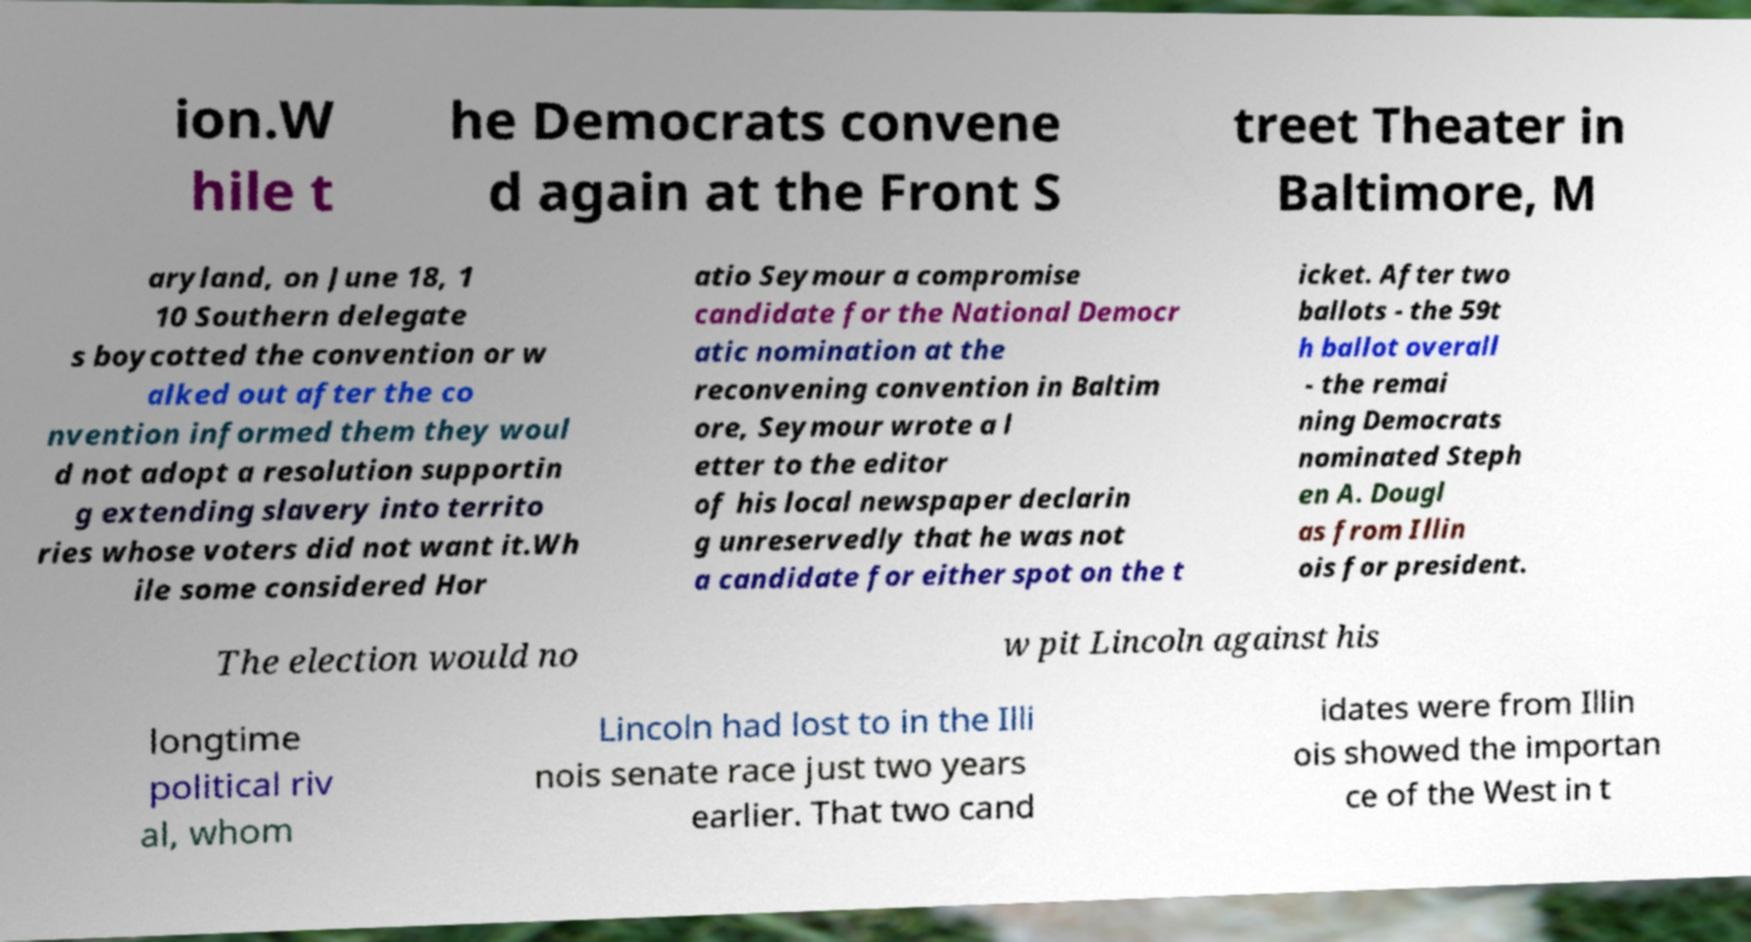Can you accurately transcribe the text from the provided image for me? ion.W hile t he Democrats convene d again at the Front S treet Theater in Baltimore, M aryland, on June 18, 1 10 Southern delegate s boycotted the convention or w alked out after the co nvention informed them they woul d not adopt a resolution supportin g extending slavery into territo ries whose voters did not want it.Wh ile some considered Hor atio Seymour a compromise candidate for the National Democr atic nomination at the reconvening convention in Baltim ore, Seymour wrote a l etter to the editor of his local newspaper declarin g unreservedly that he was not a candidate for either spot on the t icket. After two ballots - the 59t h ballot overall - the remai ning Democrats nominated Steph en A. Dougl as from Illin ois for president. The election would no w pit Lincoln against his longtime political riv al, whom Lincoln had lost to in the Illi nois senate race just two years earlier. That two cand idates were from Illin ois showed the importan ce of the West in t 